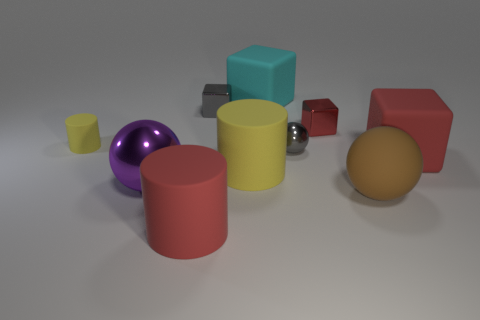Subtract all purple metal balls. How many balls are left? 2 Subtract 1 cubes. How many cubes are left? 3 Subtract all cyan cubes. How many cubes are left? 3 Subtract all blue spheres. How many yellow cylinders are left? 2 Subtract all spheres. How many objects are left? 7 Add 8 small gray shiny cubes. How many small gray shiny cubes are left? 9 Add 7 purple things. How many purple things exist? 8 Subtract 0 red spheres. How many objects are left? 10 Subtract all brown spheres. Subtract all red cubes. How many spheres are left? 2 Subtract all small blue metallic things. Subtract all large shiny objects. How many objects are left? 9 